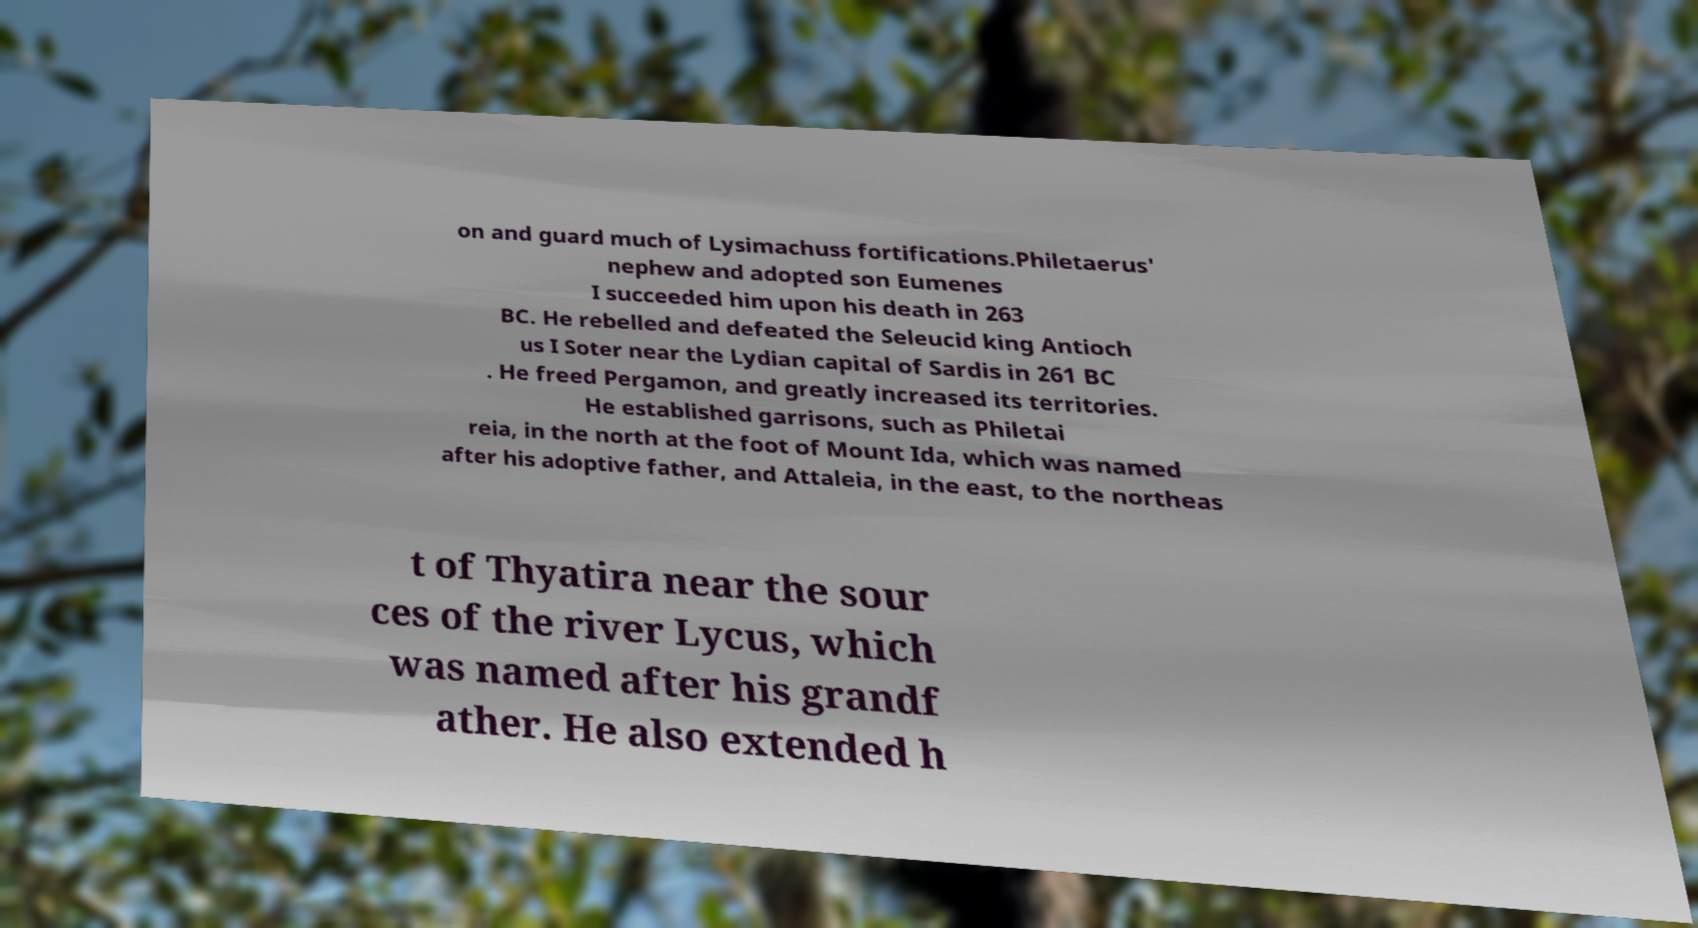Could you assist in decoding the text presented in this image and type it out clearly? on and guard much of Lysimachuss fortifications.Philetaerus' nephew and adopted son Eumenes I succeeded him upon his death in 263 BC. He rebelled and defeated the Seleucid king Antioch us I Soter near the Lydian capital of Sardis in 261 BC . He freed Pergamon, and greatly increased its territories. He established garrisons, such as Philetai reia, in the north at the foot of Mount Ida, which was named after his adoptive father, and Attaleia, in the east, to the northeas t of Thyatira near the sour ces of the river Lycus, which was named after his grandf ather. He also extended h 